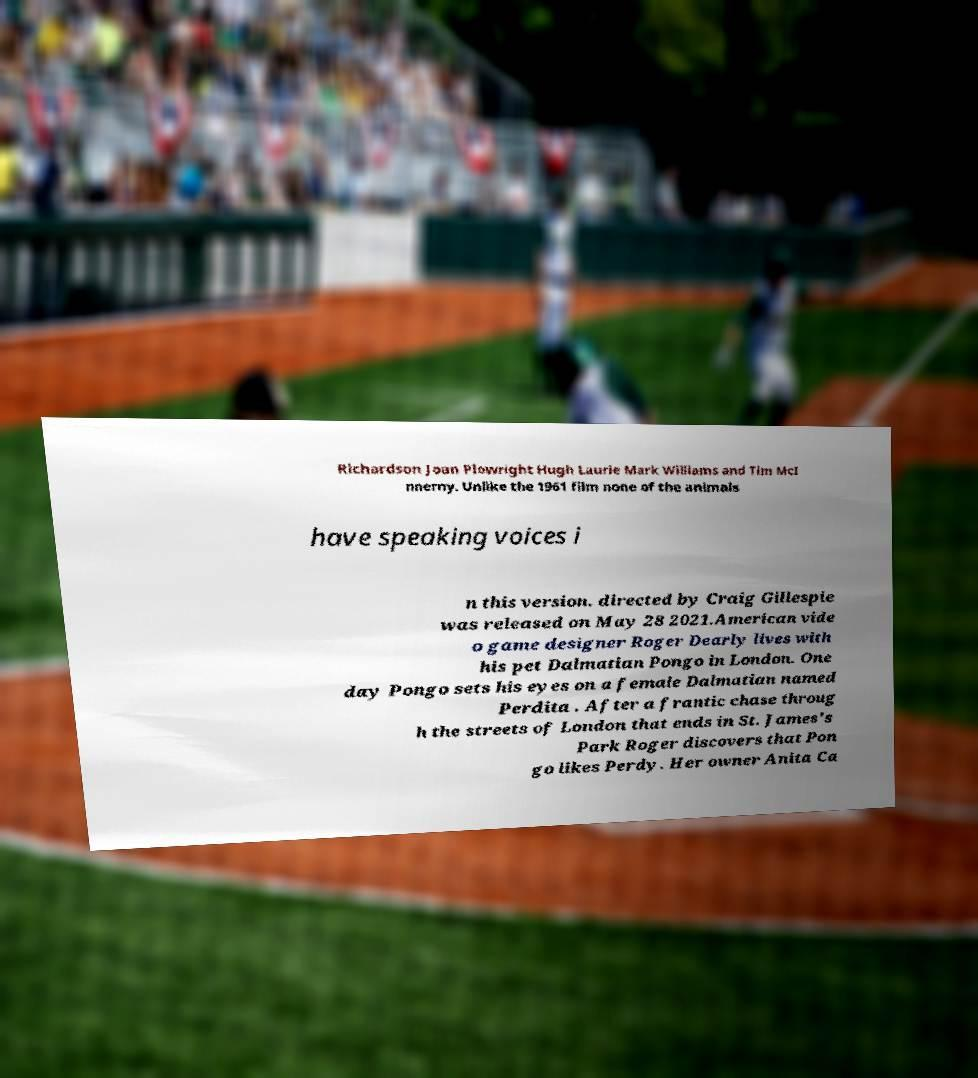Could you assist in decoding the text presented in this image and type it out clearly? Richardson Joan Plowright Hugh Laurie Mark Williams and Tim McI nnerny. Unlike the 1961 film none of the animals have speaking voices i n this version. directed by Craig Gillespie was released on May 28 2021.American vide o game designer Roger Dearly lives with his pet Dalmatian Pongo in London. One day Pongo sets his eyes on a female Dalmatian named Perdita . After a frantic chase throug h the streets of London that ends in St. James's Park Roger discovers that Pon go likes Perdy. Her owner Anita Ca 